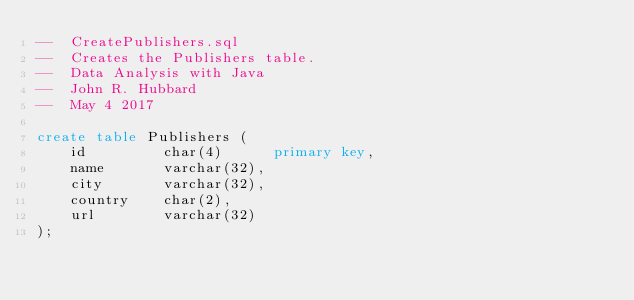<code> <loc_0><loc_0><loc_500><loc_500><_SQL_>--  CreatePublishers.sql
--  Creates the Publishers table.
--  Data Analysis with Java
--  John R. Hubbard
--  May 4 2017

create table Publishers (
    id         char(4)      primary key,
    name       varchar(32),
    city       varchar(32),
    country    char(2),
    url        varchar(32)
);
</code> 